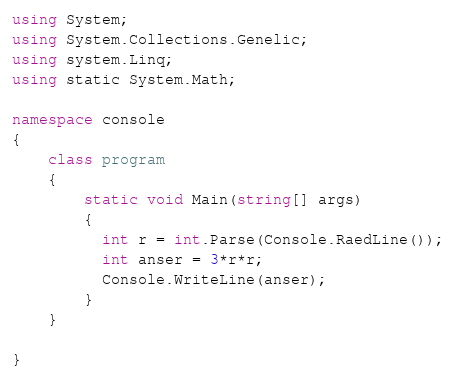<code> <loc_0><loc_0><loc_500><loc_500><_C#_>using System;
using System.Collections.Genelic;
using system.Linq;
using static System.Math;

namespace console
{
	class program
    {
    	static void Main(string[] args)
        {
          int r = int.Parse(Console.RaedLine());
          int anser = 3*r*r;
          Console.WriteLine(anser);
        }
    }
  
}
</code> 